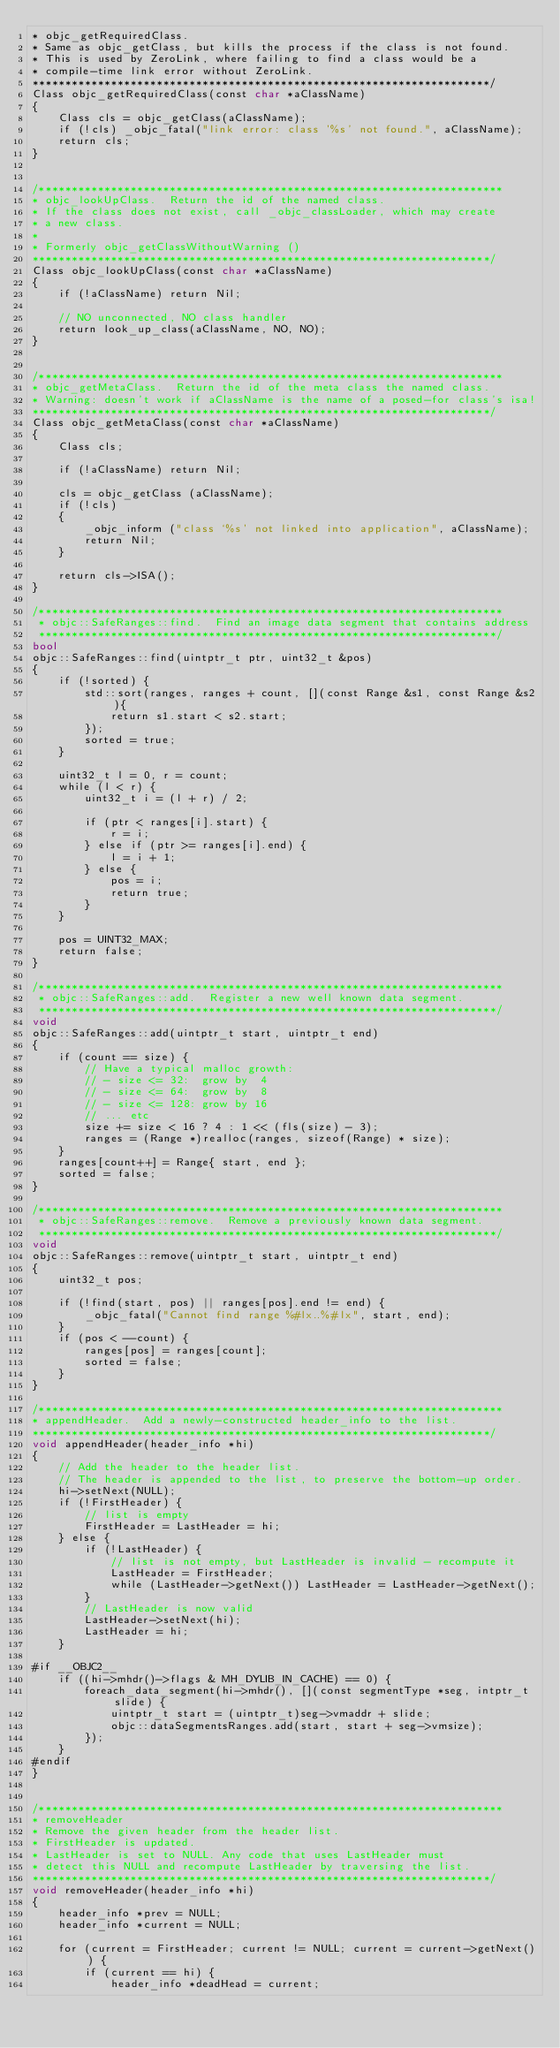<code> <loc_0><loc_0><loc_500><loc_500><_ObjectiveC_>* objc_getRequiredClass.  
* Same as objc_getClass, but kills the process if the class is not found. 
* This is used by ZeroLink, where failing to find a class would be a 
* compile-time link error without ZeroLink.
**********************************************************************/
Class objc_getRequiredClass(const char *aClassName)
{
    Class cls = objc_getClass(aClassName);
    if (!cls) _objc_fatal("link error: class '%s' not found.", aClassName);
    return cls;
}


/***********************************************************************
* objc_lookUpClass.  Return the id of the named class.
* If the class does not exist, call _objc_classLoader, which may create 
* a new class.
*
* Formerly objc_getClassWithoutWarning ()
**********************************************************************/
Class objc_lookUpClass(const char *aClassName)
{
    if (!aClassName) return Nil;

    // NO unconnected, NO class handler
    return look_up_class(aClassName, NO, NO);
}


/***********************************************************************
* objc_getMetaClass.  Return the id of the meta class the named class.
* Warning: doesn't work if aClassName is the name of a posed-for class's isa!
**********************************************************************/
Class objc_getMetaClass(const char *aClassName)
{
    Class cls;

    if (!aClassName) return Nil;

    cls = objc_getClass (aClassName);
    if (!cls)
    {
        _objc_inform ("class `%s' not linked into application", aClassName);
        return Nil;
    }

    return cls->ISA();
}

/***********************************************************************
 * objc::SafeRanges::find.  Find an image data segment that contains address
 **********************************************************************/
bool
objc::SafeRanges::find(uintptr_t ptr, uint32_t &pos)
{
    if (!sorted) {
        std::sort(ranges, ranges + count, [](const Range &s1, const Range &s2){
            return s1.start < s2.start;
        });
        sorted = true;
    }

    uint32_t l = 0, r = count;
    while (l < r) {
        uint32_t i = (l + r) / 2;

        if (ptr < ranges[i].start) {
            r = i;
        } else if (ptr >= ranges[i].end) {
            l = i + 1;
        } else {
            pos = i;
            return true;
        }
    }

    pos = UINT32_MAX;
    return false;
}

/***********************************************************************
 * objc::SafeRanges::add.  Register a new well known data segment.
 **********************************************************************/
void
objc::SafeRanges::add(uintptr_t start, uintptr_t end)
{
    if (count == size) {
        // Have a typical malloc growth:
        // - size <= 32:  grow by  4
        // - size <= 64:  grow by  8
        // - size <= 128: grow by 16
        // ... etc
        size += size < 16 ? 4 : 1 << (fls(size) - 3);
        ranges = (Range *)realloc(ranges, sizeof(Range) * size);
    }
    ranges[count++] = Range{ start, end };
    sorted = false;
}

/***********************************************************************
 * objc::SafeRanges::remove.  Remove a previously known data segment.
 **********************************************************************/
void
objc::SafeRanges::remove(uintptr_t start, uintptr_t end)
{
    uint32_t pos;

    if (!find(start, pos) || ranges[pos].end != end) {
        _objc_fatal("Cannot find range %#lx..%#lx", start, end);
    }
    if (pos < --count) {
        ranges[pos] = ranges[count];
        sorted = false;
    }
}

/***********************************************************************
* appendHeader.  Add a newly-constructed header_info to the list. 
**********************************************************************/
void appendHeader(header_info *hi)
{
    // Add the header to the header list. 
    // The header is appended to the list, to preserve the bottom-up order.
    hi->setNext(NULL);
    if (!FirstHeader) {
        // list is empty
        FirstHeader = LastHeader = hi;
    } else {
        if (!LastHeader) {
            // list is not empty, but LastHeader is invalid - recompute it
            LastHeader = FirstHeader;
            while (LastHeader->getNext()) LastHeader = LastHeader->getNext();
        }
        // LastHeader is now valid
        LastHeader->setNext(hi);
        LastHeader = hi;
    }

#if __OBJC2__
    if ((hi->mhdr()->flags & MH_DYLIB_IN_CACHE) == 0) {
        foreach_data_segment(hi->mhdr(), [](const segmentType *seg, intptr_t slide) {
            uintptr_t start = (uintptr_t)seg->vmaddr + slide;
            objc::dataSegmentsRanges.add(start, start + seg->vmsize);
        });
    }
#endif
}


/***********************************************************************
* removeHeader
* Remove the given header from the header list.
* FirstHeader is updated. 
* LastHeader is set to NULL. Any code that uses LastHeader must 
* detect this NULL and recompute LastHeader by traversing the list.
**********************************************************************/
void removeHeader(header_info *hi)
{
    header_info *prev = NULL;
    header_info *current = NULL;

    for (current = FirstHeader; current != NULL; current = current->getNext()) {
        if (current == hi) {
            header_info *deadHead = current;
</code> 